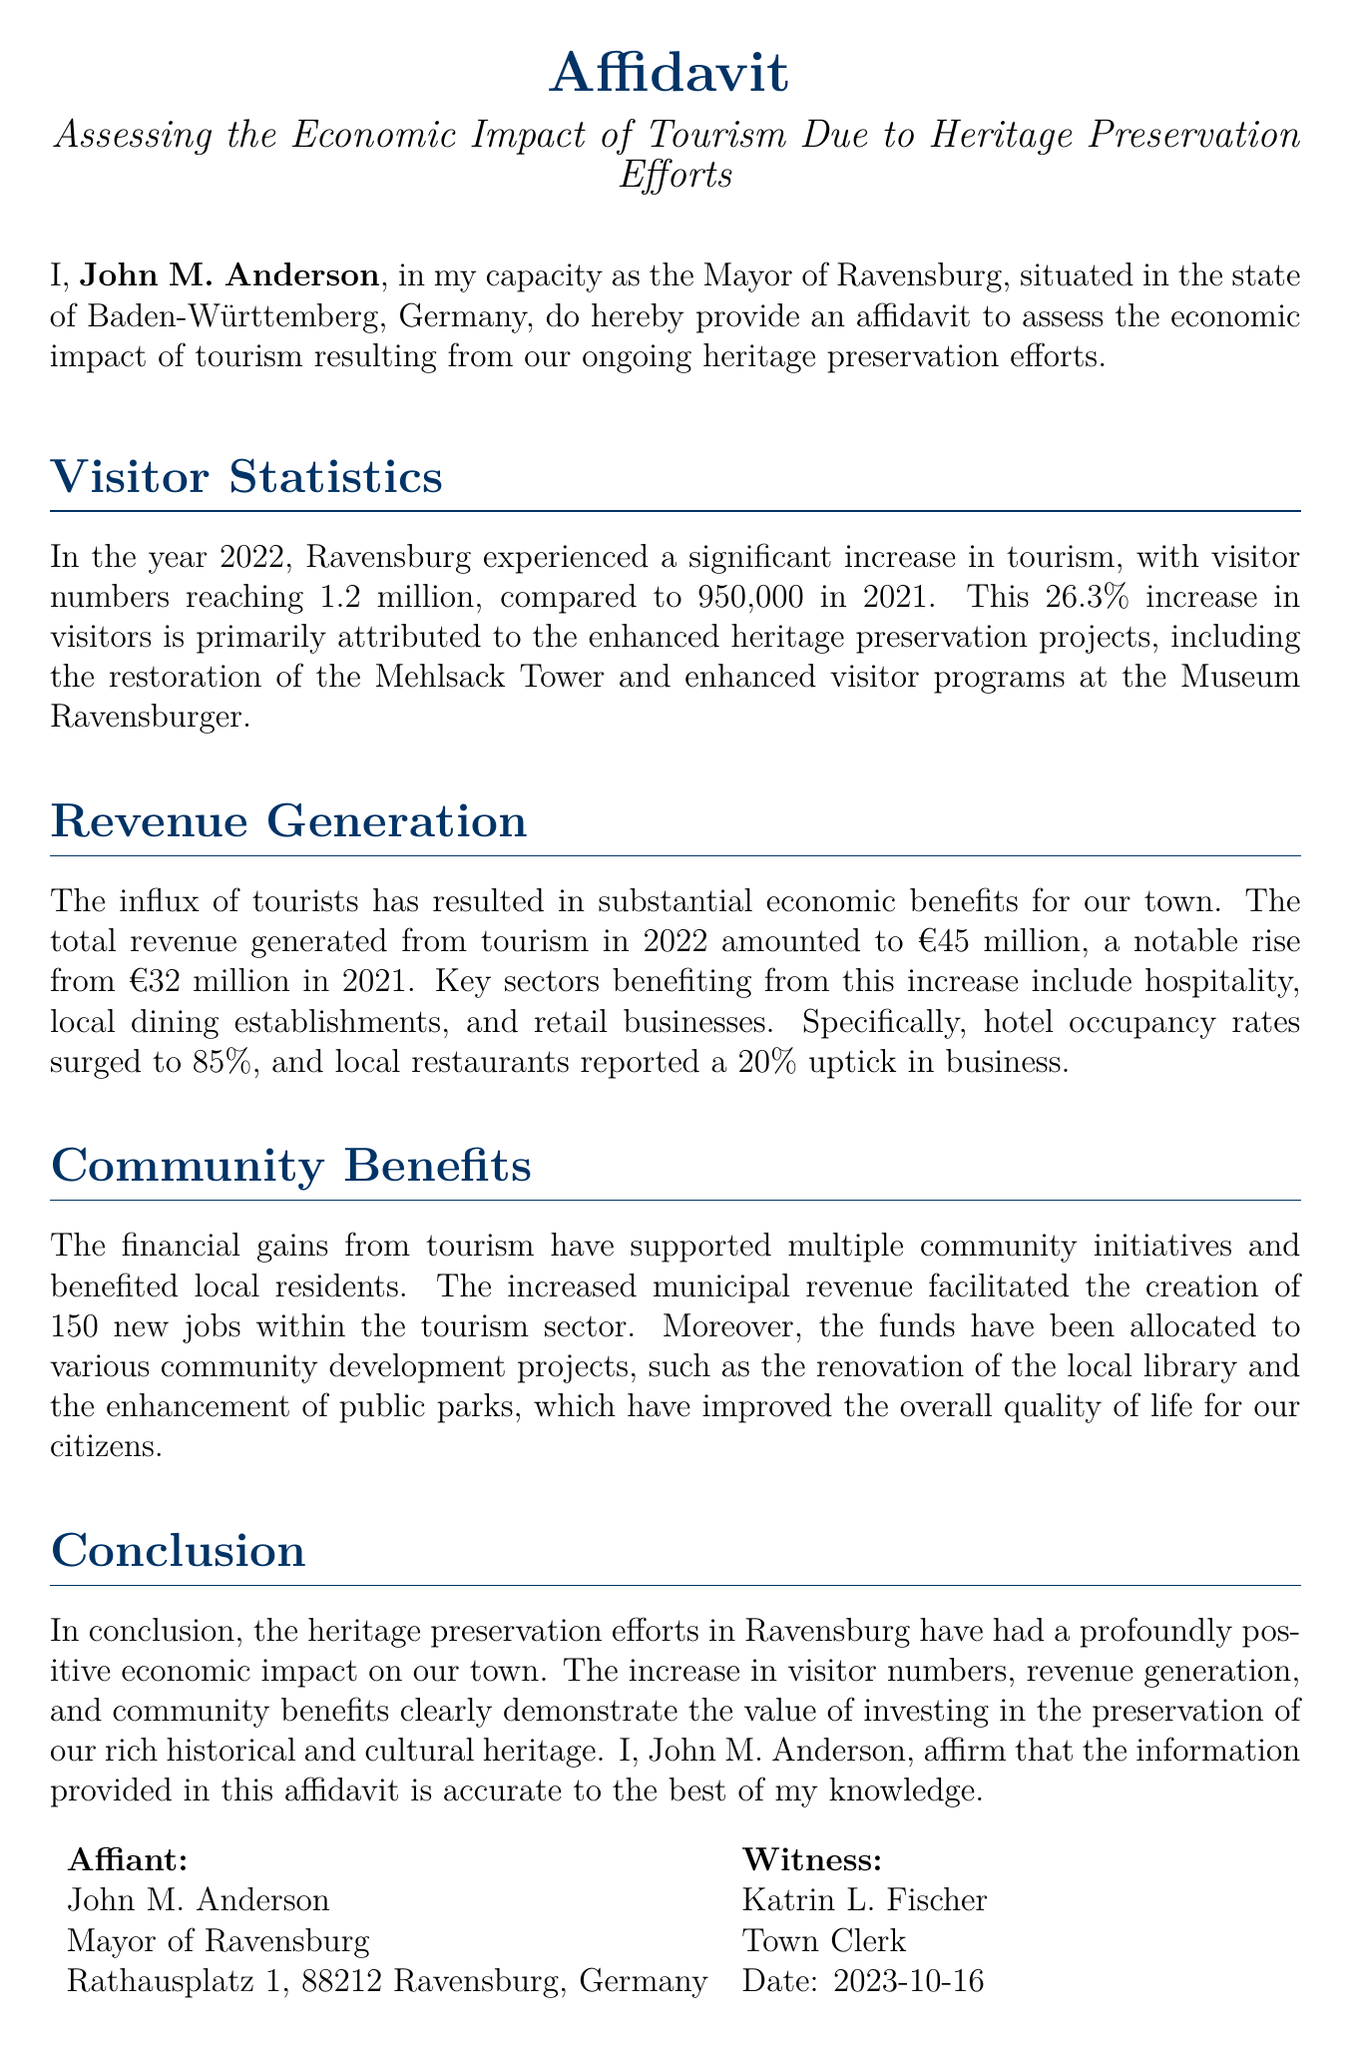what is the name of the affiant? The affiant is the person who provides the affidavit, which is stated as John M. Anderson.
Answer: John M. Anderson what year did visitor numbers reach 1.2 million? The document states that this visitor number was achieved in 2022.
Answer: 2022 how much total revenue was generated from tourism in 2022? The document specifies that the total revenue for 2022 amounted to €45 million.
Answer: €45 million how many new jobs were created within the tourism sector? The affidavit mentions the creation of 150 new jobs as a result of increased tourism.
Answer: 150 what was the increase in visitor numbers from 2021 to 2022? The document notes a 26.3% increase in visitors between the years mentioned.
Answer: 26.3% what percentage of hotel occupancy was reported? This information is indicated as 85% occupancy for hotels in the town.
Answer: 85% which two heritage preservation projects are mentioned? The document refers specifically to the Mehlsack Tower and the Museum Ravensburger.
Answer: Mehlsack Tower and Museum Ravensburger what is the title of this document? The title of the document indicates its purpose, specifically assessing the economic impact of tourism due to heritage preservation efforts.
Answer: Affidavit Assessing the Economic Impact of Tourism Due to Heritage Preservation Efforts what community project was funded by tourism revenue? The affidavit mentions the renovation of the local library as a community project supported by the funds.
Answer: renovation of the local library 